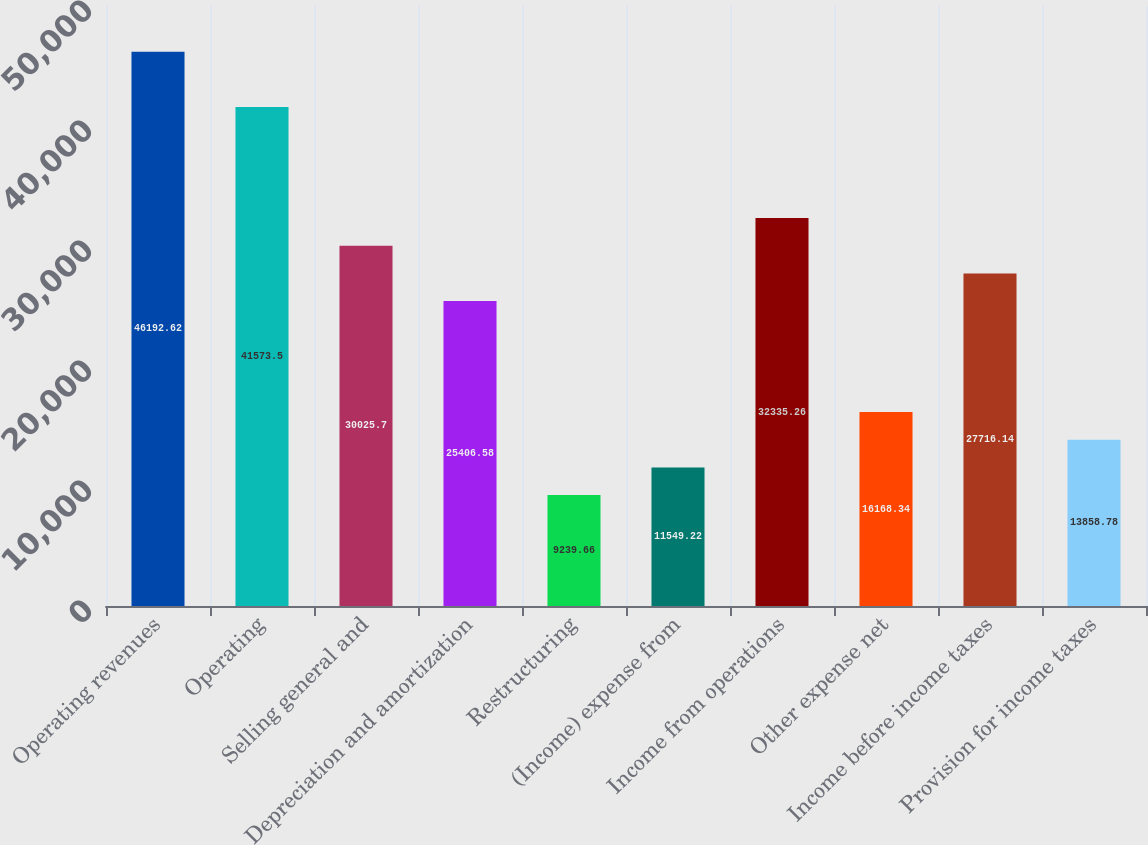Convert chart to OTSL. <chart><loc_0><loc_0><loc_500><loc_500><bar_chart><fcel>Operating revenues<fcel>Operating<fcel>Selling general and<fcel>Depreciation and amortization<fcel>Restructuring<fcel>(Income) expense from<fcel>Income from operations<fcel>Other expense net<fcel>Income before income taxes<fcel>Provision for income taxes<nl><fcel>46192.6<fcel>41573.5<fcel>30025.7<fcel>25406.6<fcel>9239.66<fcel>11549.2<fcel>32335.3<fcel>16168.3<fcel>27716.1<fcel>13858.8<nl></chart> 